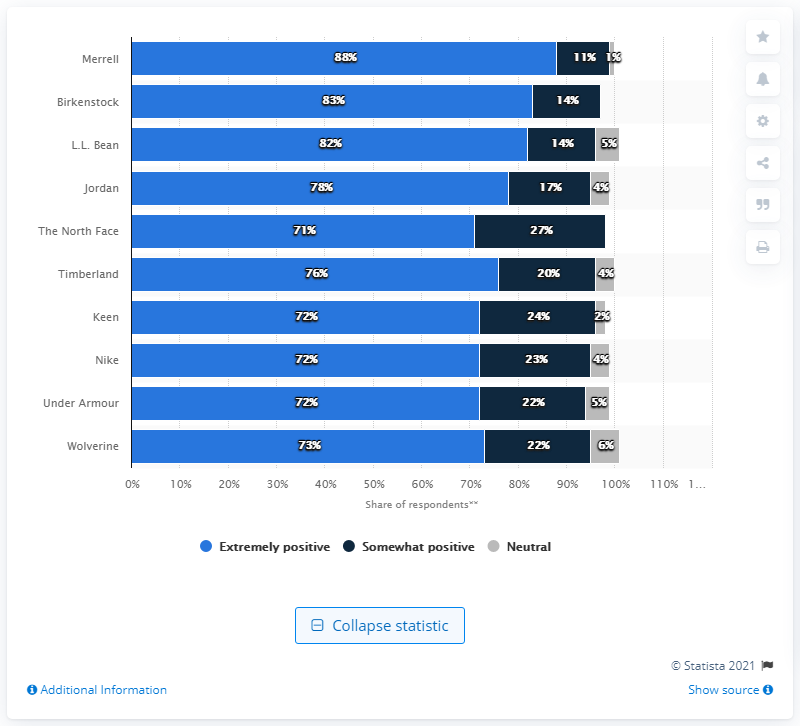Give some essential details in this illustration. According to a survey of consumers, 88% reported having an extremely positive impression of Merrel's quality. 